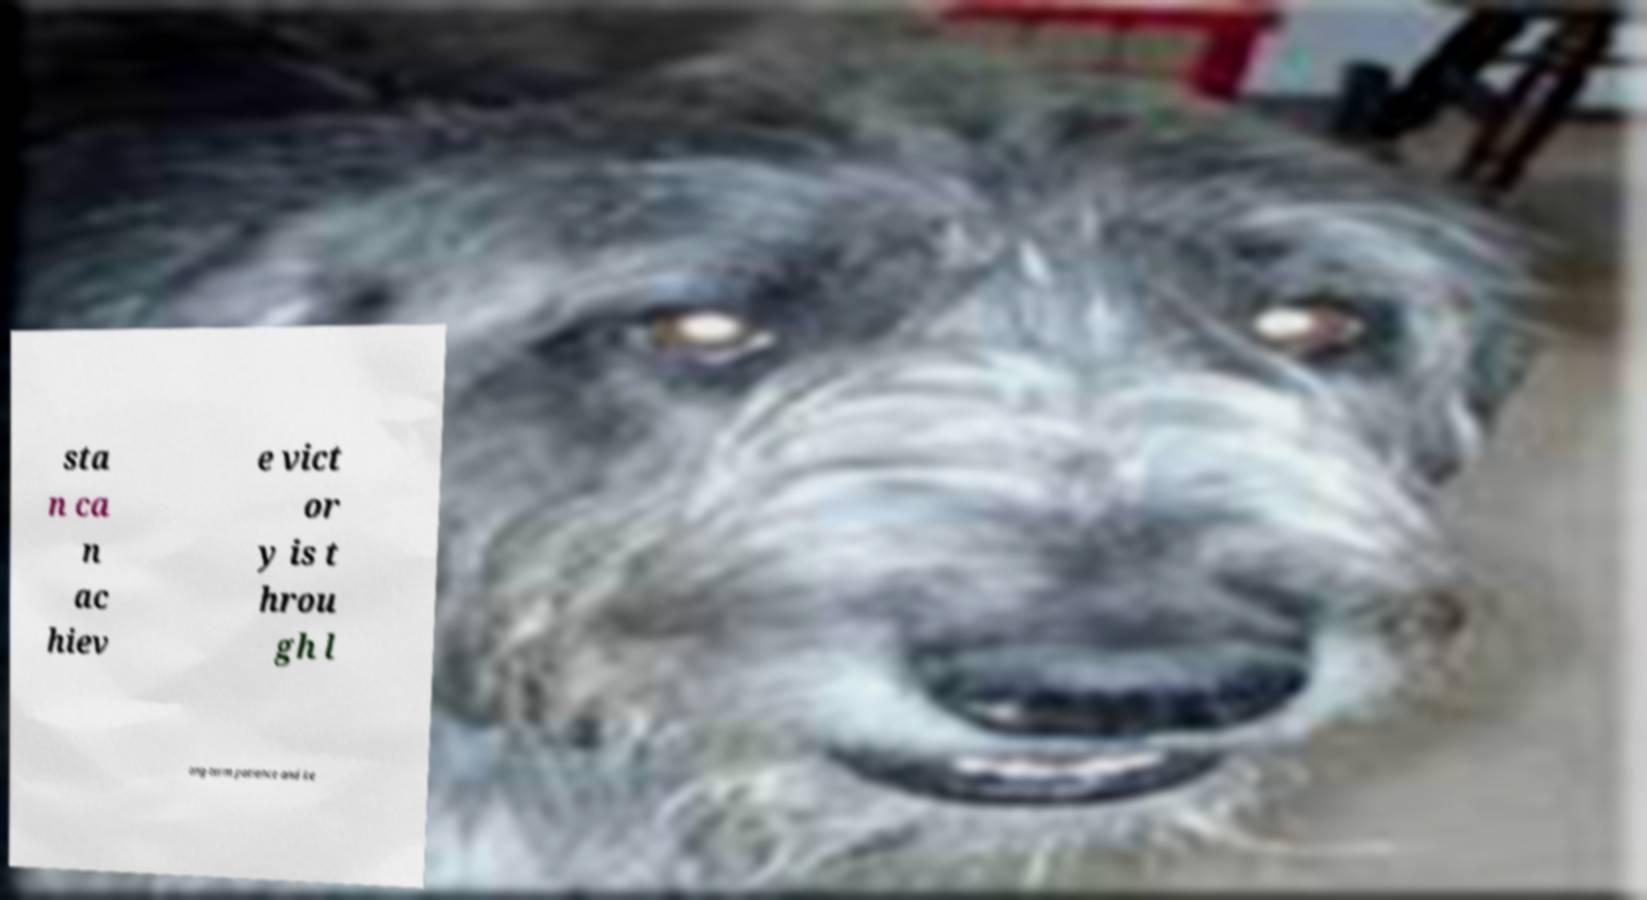Please read and relay the text visible in this image. What does it say? sta n ca n ac hiev e vict or y is t hrou gh l ong-term patience and ke 